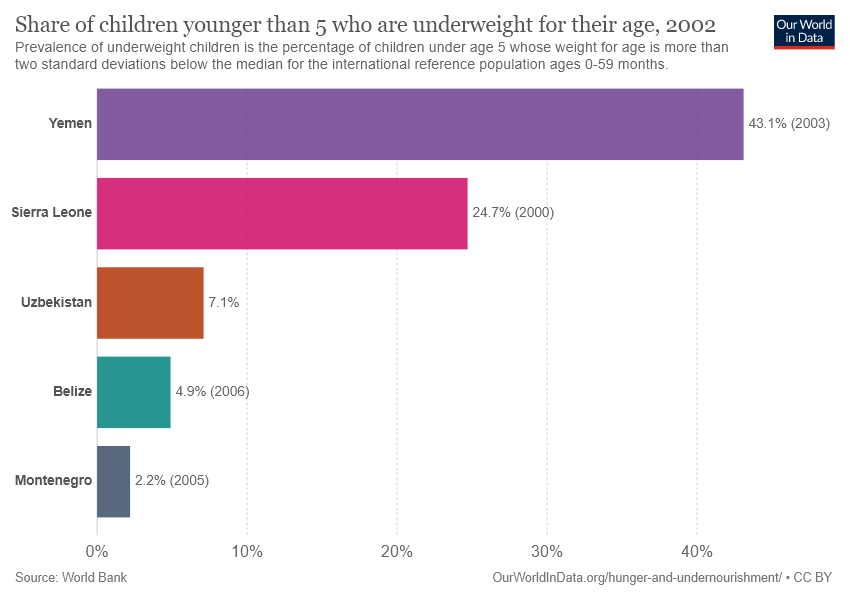Identify some key points in this picture. The color that is associated with Yemen is purple. The sum of the last three lowest bars is 14.2. 